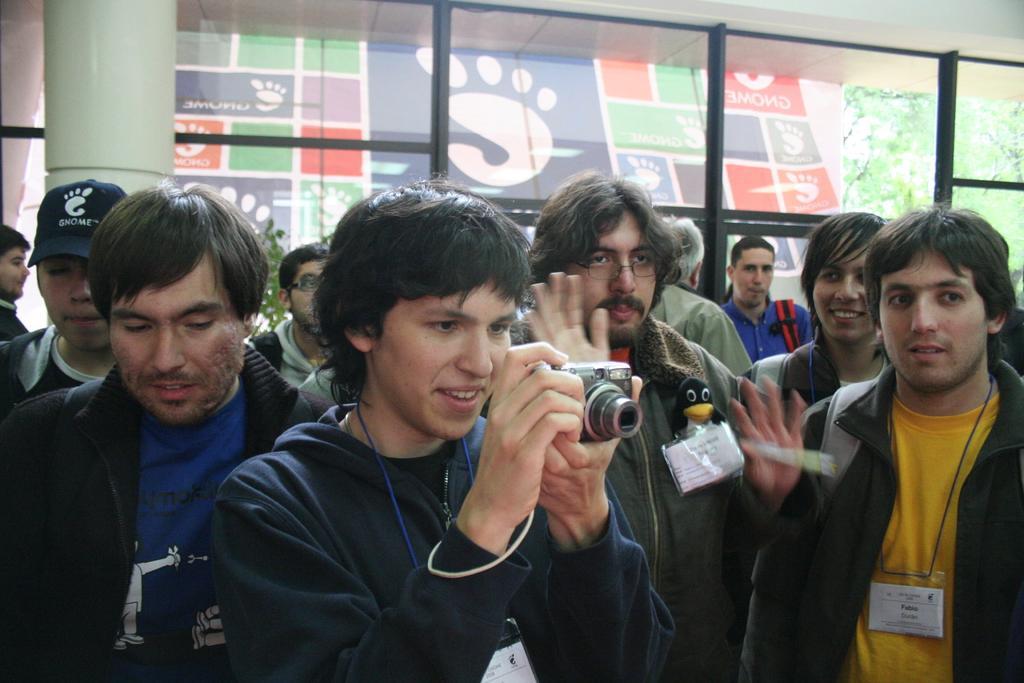Could you give a brief overview of what you see in this image? In this image, there are group of people standing. In a middle, a person is holding a camera and clicking photos. In the background, a window is visible and a pillar of green color is visible. And a poster is visible. In the right middle, trees are visible. This image is taken inside a hall. 